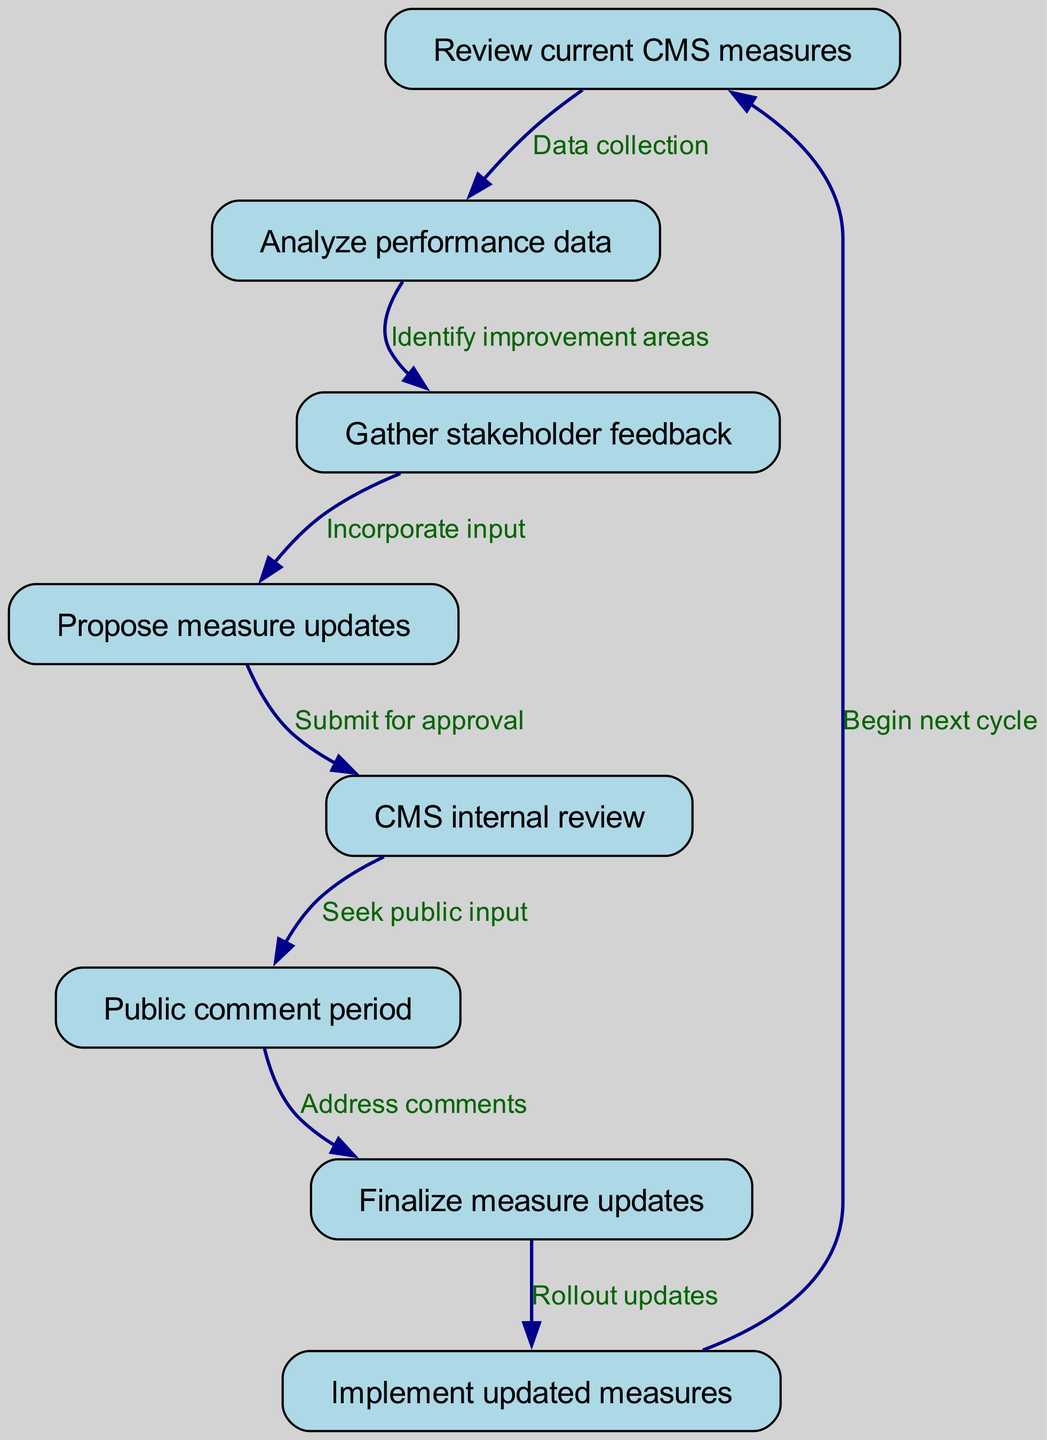What are the first two nodes in the process flow? The first two nodes in the process flow are "Review current CMS measures" and "Analyze performance data". The diagram clearly shows the starting point of the cycle with "Review current CMS measures" as the first node, leading to "Analyze performance data" as the second node.
Answer: Review current CMS measures, Analyze performance data How many nodes are there in the diagram? The diagram includes a total of eight distinct nodes that represent different stages in the annual review and update cycle for CMS quality measures. This is evidenced by the enumeration of unique steps from reviewing measures to implementing updates.
Answer: Eight What comes after "Public comment period"? The step that comes after "Public comment period" is "Finalize measure updates". This follows directly in the flow of the diagram as indicated by the edge connecting these two nodes.
Answer: Finalize measure updates Which node proposes updates based on stakeholder feedback? The node that proposes updates based on stakeholder feedback is "Propose measure updates". This node is reached after the "Gather stakeholder feedback" node in the process flow, indicating it incorporates the feedback collected.
Answer: Propose measure updates What is the relationship between "CMS internal review" and "Public comment period"? The relationship is that "CMS internal review" comes directly before "Public comment period", as indicated by the directed edge between these two nodes in the diagram. This shows that the internal review process is followed by seeking public input.
Answer: CMS internal review comes before Public comment period Which phase marks the beginning of the next cycle? The phase that marks the beginning of the next cycle is "Begin next cycle". This is represented at the end of the diagram where the flow loops back to the start after implementing the updated measures.
Answer: Begin next cycle How many edges are there in total? There are a total of seven edges connecting the eight nodes in the document. Each edge represents a directed flow from one stage to the next in the annual review and update process.
Answer: Seven What action is taken after the "Finalize measure updates" node? After "Finalize measure updates", the action taken is to "Implement updated measures". This indicates that the finalized updates are put into action immediately following their finalization.
Answer: Implement updated measures 